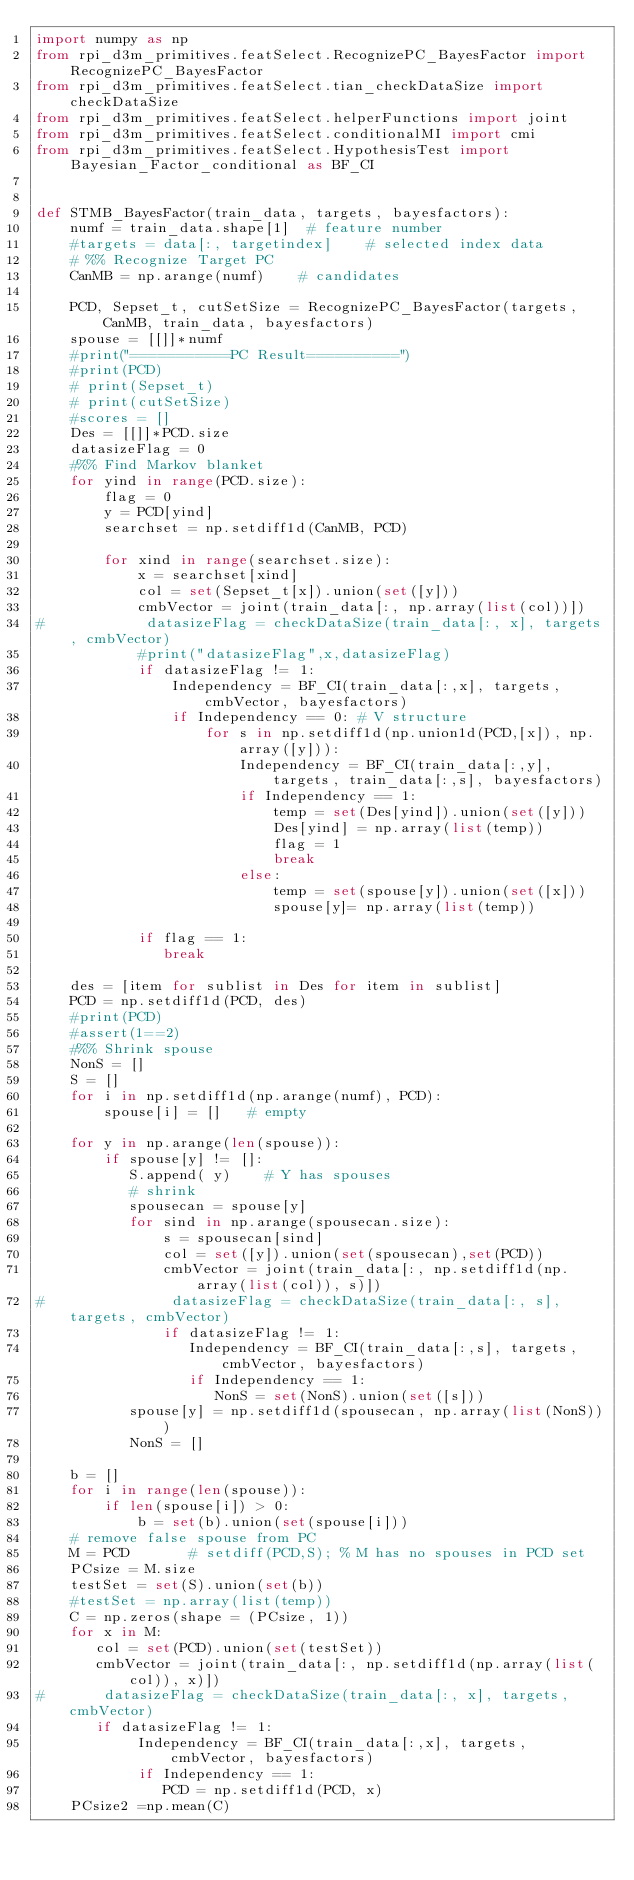Convert code to text. <code><loc_0><loc_0><loc_500><loc_500><_Python_>import numpy as np
from rpi_d3m_primitives.featSelect.RecognizePC_BayesFactor import RecognizePC_BayesFactor
from rpi_d3m_primitives.featSelect.tian_checkDataSize import checkDataSize
from rpi_d3m_primitives.featSelect.helperFunctions import joint
from rpi_d3m_primitives.featSelect.conditionalMI import cmi
from rpi_d3m_primitives.featSelect.HypothesisTest import Bayesian_Factor_conditional as BF_CI


def STMB_BayesFactor(train_data, targets, bayesfactors): 
    numf = train_data.shape[1]  # feature number
    #targets = data[:, targetindex]    # selected index data 
    # %% Recognize Target PC
    CanMB = np.arange(numf)    # candidates
    
    PCD, Sepset_t, cutSetSize = RecognizePC_BayesFactor(targets, CanMB, train_data, bayesfactors)
    spouse = [[]]*numf
    #print("===========PC Result==========")
    #print(PCD)
    # print(Sepset_t)
    # print(cutSetSize)
    #scores = []
    Des = [[]]*PCD.size
    datasizeFlag = 0
    #%% Find Markov blanket
    for yind in range(PCD.size):
        flag = 0
        y = PCD[yind]
        searchset = np.setdiff1d(CanMB, PCD)
        
        for xind in range(searchset.size):
            x = searchset[xind]
            col = set(Sepset_t[x]).union(set([y]))
            cmbVector = joint(train_data[:, np.array(list(col))])
#            datasizeFlag = checkDataSize(train_data[:, x], targets, cmbVector)
            #print("datasizeFlag",x,datasizeFlag)
            if datasizeFlag != 1:
                Independency = BF_CI(train_data[:,x], targets, cmbVector, bayesfactors)          
                if Independency == 0: # V structure
                    for s in np.setdiff1d(np.union1d(PCD,[x]), np.array([y])): 
                        Independency = BF_CI(train_data[:,y], targets, train_data[:,s], bayesfactors)
                        if Independency == 1:
                            temp = set(Des[yind]).union(set([y]))
                            Des[yind] = np.array(list(temp))
                            flag = 1
                            break
                        else:
                            temp = set(spouse[y]).union(set([x]))
                            spouse[y]= np.array(list(temp))

            if flag == 1:                            
               break
    
    des = [item for sublist in Des for item in sublist]
    PCD = np.setdiff1d(PCD, des)
    #print(PCD)
    #assert(1==2)
    #%% Shrink spouse
    NonS = []
    S = []
    for i in np.setdiff1d(np.arange(numf), PCD):
        spouse[i] = []   # empty                                     

    for y in np.arange(len(spouse)):
        if spouse[y] != []:
           S.append( y)    # Y has spouses
           # shrink
           spousecan = spouse[y]
           for sind in np.arange(spousecan.size):
               s = spousecan[sind]
               col = set([y]).union(set(spousecan),set(PCD))
               cmbVector = joint(train_data[:, np.setdiff1d(np.array(list(col)), s)])
#               datasizeFlag = checkDataSize(train_data[:, s], targets, cmbVector)
               if datasizeFlag != 1:
                  Independency = BF_CI(train_data[:,s], targets, cmbVector, bayesfactors)
                  if Independency == 1:
                     NonS = set(NonS).union(set([s]))
           spouse[y] = np.setdiff1d(spousecan, np.array(list(NonS)))
           NonS = []
                                                            
    b = []
    for i in range(len(spouse)):
        if len(spouse[i]) > 0:
            b = set(b).union(set(spouse[i]))
    # remove false spouse from PC
    M = PCD       # setdiff(PCD,S); % M has no spouses in PCD set
    PCsize = M.size
    testSet = set(S).union(set(b))
    #testSet = np.array(list(temp))
    C = np.zeros(shape = (PCsize, 1))
    for x in M:
       col = set(PCD).union(set(testSet))
       cmbVector = joint(train_data[:, np.setdiff1d(np.array(list(col)), x)])
#       datasizeFlag = checkDataSize(train_data[:, x], targets, cmbVector)
       if datasizeFlag != 1:
            Independency = BF_CI(train_data[:,x], targets, cmbVector, bayesfactors)
            if Independency == 1:
               PCD = np.setdiff1d(PCD, x)                                                                      
    PCsize2 =np.mean(C)</code> 